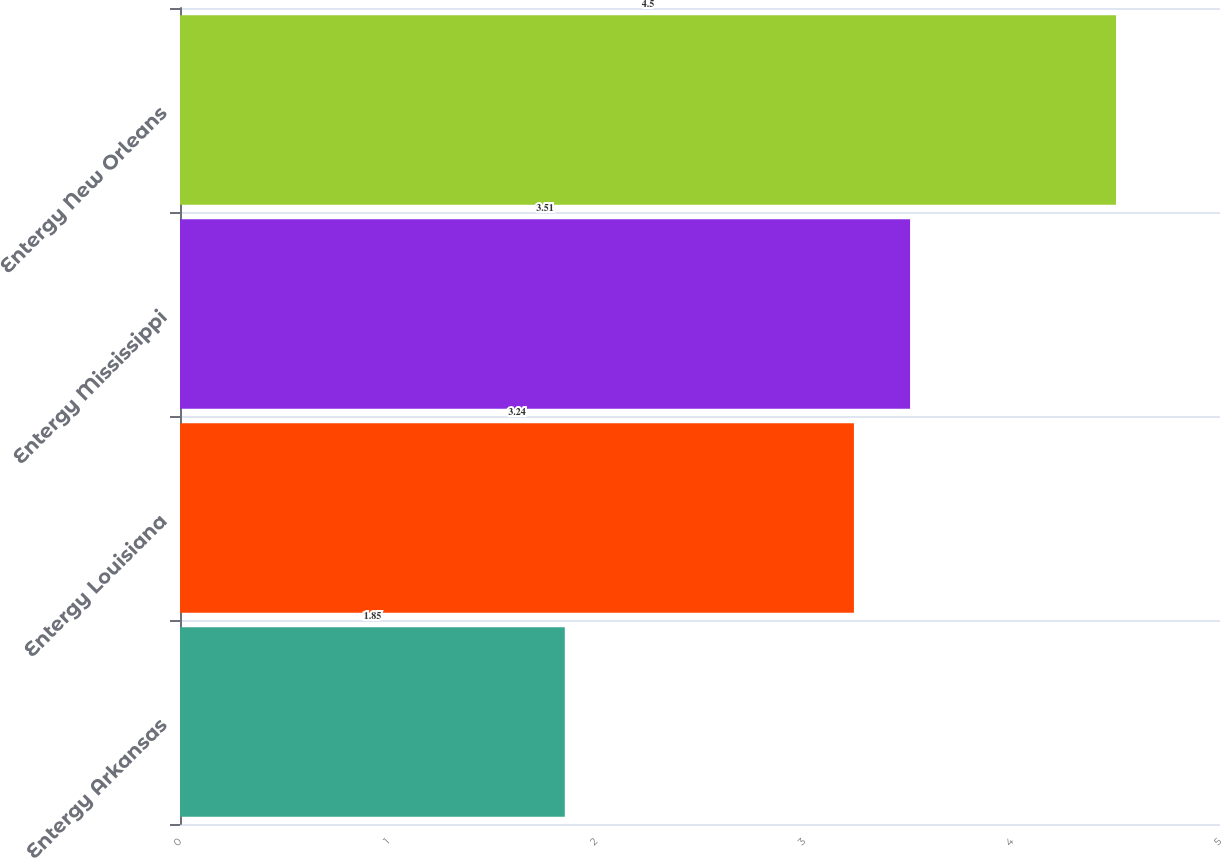<chart> <loc_0><loc_0><loc_500><loc_500><bar_chart><fcel>Entergy Arkansas<fcel>Entergy Louisiana<fcel>Entergy Mississippi<fcel>Entergy New Orleans<nl><fcel>1.85<fcel>3.24<fcel>3.51<fcel>4.5<nl></chart> 